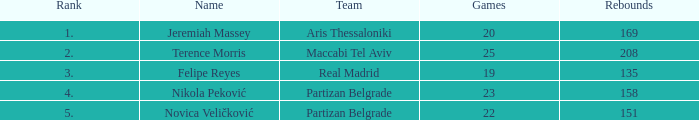What is the number of Games for the Maccabi Tel Aviv Team with less than 208 Rebounds? None. Help me parse the entirety of this table. {'header': ['Rank', 'Name', 'Team', 'Games', 'Rebounds'], 'rows': [['1.', 'Jeremiah Massey', 'Aris Thessaloniki', '20', '169'], ['2.', 'Terence Morris', 'Maccabi Tel Aviv', '25', '208'], ['3.', 'Felipe Reyes', 'Real Madrid', '19', '135'], ['4.', 'Nikola Peković', 'Partizan Belgrade', '23', '158'], ['5.', 'Novica Veličković', 'Partizan Belgrade', '22', '151']]} 